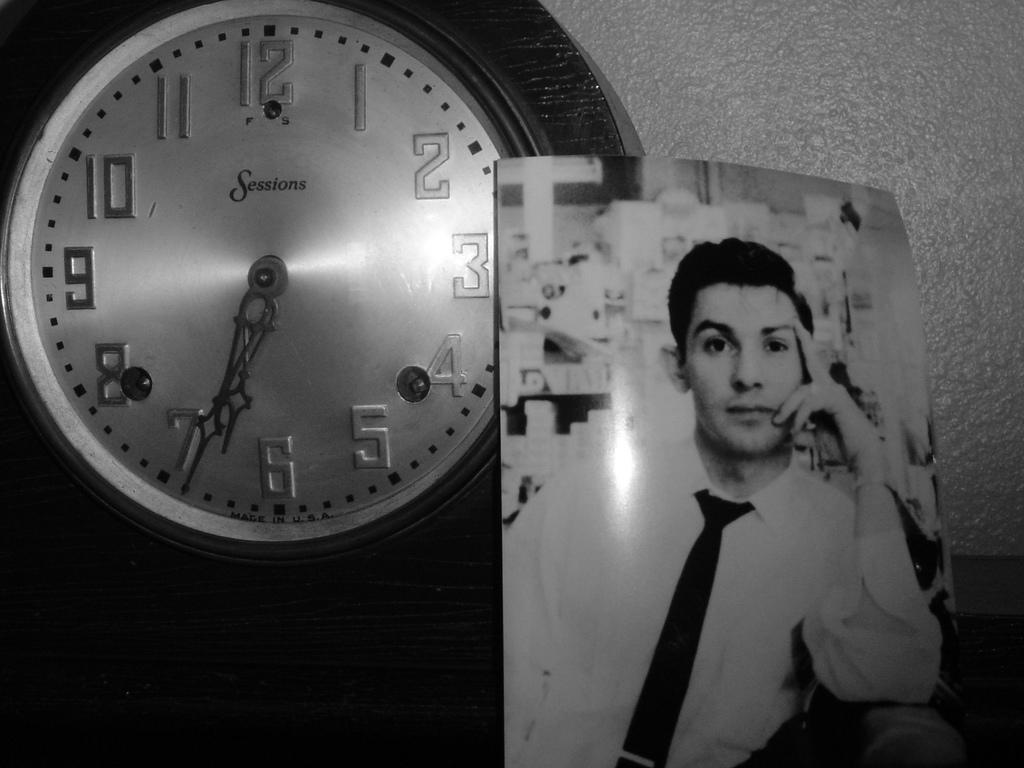<image>
Present a compact description of the photo's key features. A Sessions clock is hanging on the wall 